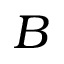Convert formula to latex. <formula><loc_0><loc_0><loc_500><loc_500>B</formula> 